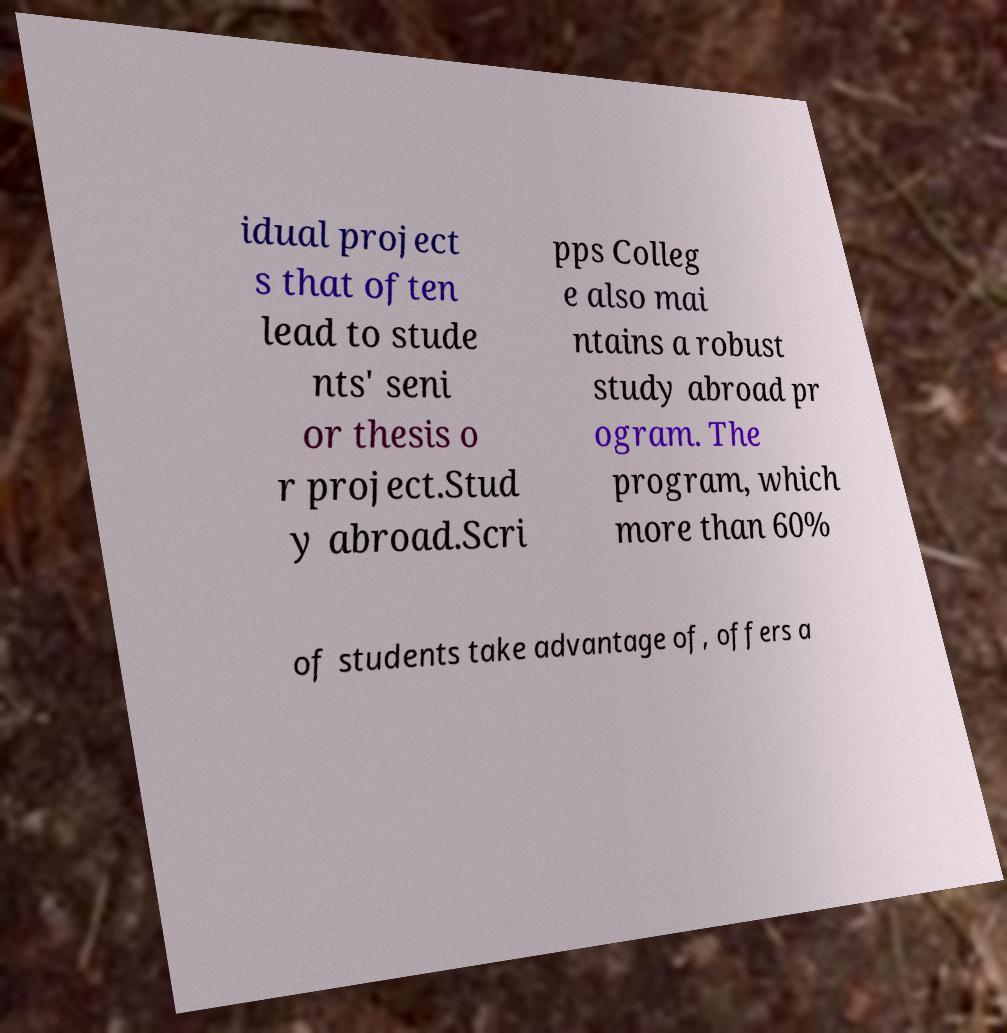What messages or text are displayed in this image? I need them in a readable, typed format. idual project s that often lead to stude nts' seni or thesis o r project.Stud y abroad.Scri pps Colleg e also mai ntains a robust study abroad pr ogram. The program, which more than 60% of students take advantage of, offers a 